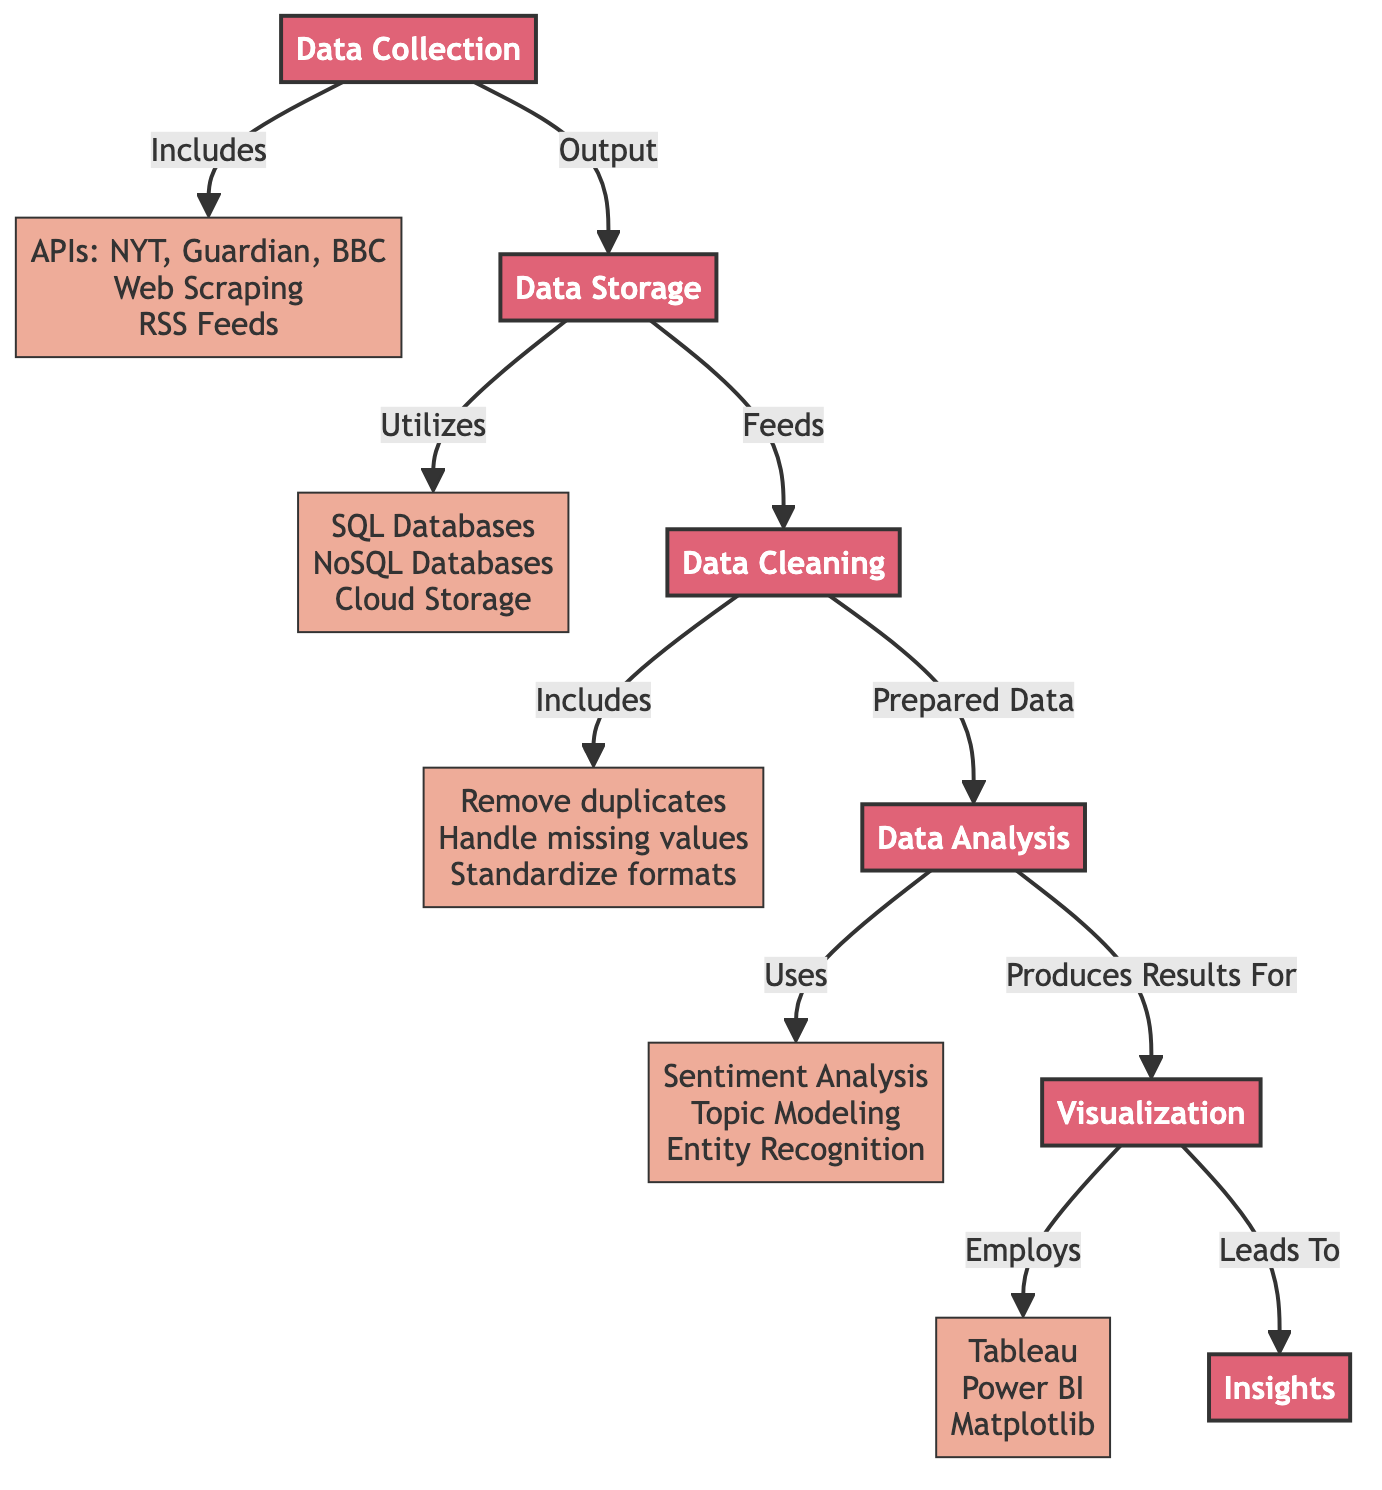What is the first step in the data pipeline? The first step according to the diagram is labeled as "Data Collection." It serves as the starting point for the entire pipeline.
Answer: Data Collection How many main processes are depicted in the diagram? The diagram shows five main processes listed: Data Collection, Data Storage, Data Cleaning, Data Analysis, and Visualization, that lead to Insights.
Answer: Five What sources are included for data collection? The diagram specifies that the sources include APIs like NYT, Guardian, BBC, Web Scraping, and RSS Feeds as part of the Data Collection process.
Answer: APIs: NYT, Guardian, BBC, Web Scraping, RSS Feeds What type of storage solutions are mentioned in the diagram? The storage solutions listed are SQL Databases, NoSQL Databases, and Cloud Storage under the Data Storage process.
Answer: SQL Databases, NoSQL Databases, Cloud Storage What cleaning steps are included before data analysis? The steps include removing duplicates, handling missing values, and standardizing formats as part of the Data Cleaning process.
Answer: Remove duplicates, Handle missing values, Standardize formats Which techniques are used in the data analysis process? The diagram points out several techniques used in Data Analysis including Sentiment Analysis, Topic Modeling, and Entity Recognition.
Answer: Sentiment Analysis, Topic Modeling, Entity Recognition How does data flow from Data Storage to Data Cleaning? The Data Storage process directly feeds into the Data Cleaning process, allowing for data preparation before analysis.
Answer: Feeds What is the output of the entire data pipeline? The final output demonstrated in the diagram is labeled as Insights, which encapsulates the results obtained from the prior processes.
Answer: Insights What visualization tools are employed in the diagram? The tools mentioned for visualization are Tableau, Power BI, and Matplotlib, which help in presenting the results visually.
Answer: Tableau, Power BI, Matplotlib 